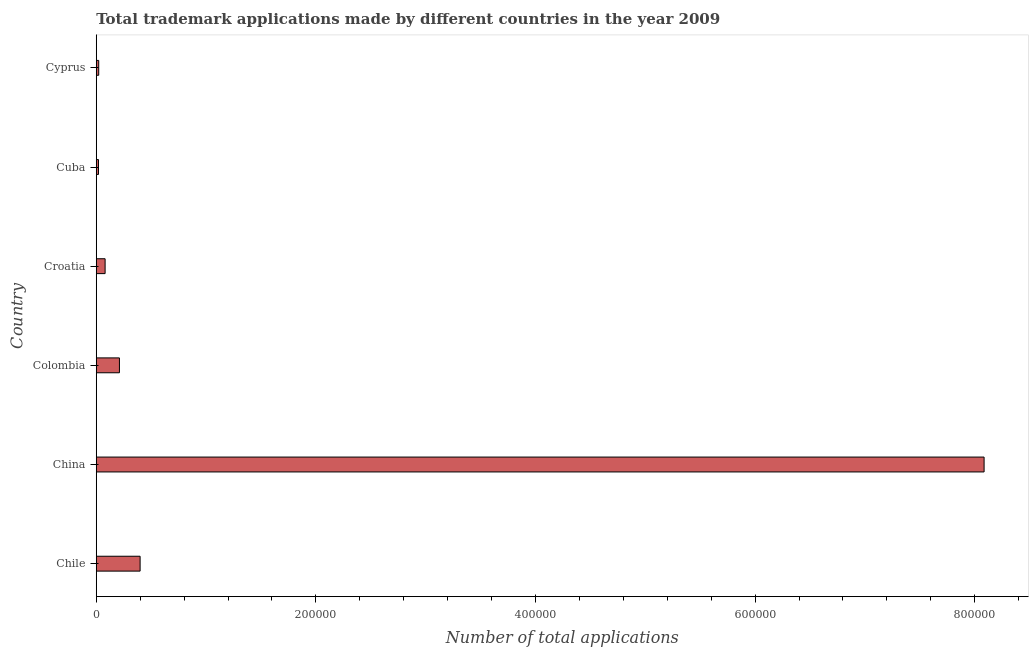Does the graph contain any zero values?
Ensure brevity in your answer.  No. What is the title of the graph?
Your answer should be very brief. Total trademark applications made by different countries in the year 2009. What is the label or title of the X-axis?
Offer a very short reply. Number of total applications. What is the number of trademark applications in Colombia?
Your answer should be very brief. 2.11e+04. Across all countries, what is the maximum number of trademark applications?
Provide a short and direct response. 8.09e+05. Across all countries, what is the minimum number of trademark applications?
Give a very brief answer. 2042. In which country was the number of trademark applications minimum?
Provide a short and direct response. Cuba. What is the sum of the number of trademark applications?
Your answer should be compact. 8.82e+05. What is the difference between the number of trademark applications in Croatia and Cyprus?
Keep it short and to the point. 5811. What is the average number of trademark applications per country?
Keep it short and to the point. 1.47e+05. What is the median number of trademark applications?
Provide a succinct answer. 1.46e+04. What is the ratio of the number of trademark applications in Croatia to that in Cuba?
Your answer should be very brief. 3.94. Is the number of trademark applications in Colombia less than that in Cuba?
Your answer should be compact. No. Is the difference between the number of trademark applications in Chile and China greater than the difference between any two countries?
Your answer should be compact. No. What is the difference between the highest and the second highest number of trademark applications?
Keep it short and to the point. 7.69e+05. What is the difference between the highest and the lowest number of trademark applications?
Offer a terse response. 8.07e+05. In how many countries, is the number of trademark applications greater than the average number of trademark applications taken over all countries?
Provide a short and direct response. 1. How many bars are there?
Provide a succinct answer. 6. How many countries are there in the graph?
Give a very brief answer. 6. What is the difference between two consecutive major ticks on the X-axis?
Make the answer very short. 2.00e+05. Are the values on the major ticks of X-axis written in scientific E-notation?
Your answer should be very brief. No. What is the Number of total applications in Chile?
Your answer should be compact. 3.99e+04. What is the Number of total applications in China?
Offer a very short reply. 8.09e+05. What is the Number of total applications of Colombia?
Offer a very short reply. 2.11e+04. What is the Number of total applications of Croatia?
Provide a succinct answer. 8055. What is the Number of total applications in Cuba?
Give a very brief answer. 2042. What is the Number of total applications of Cyprus?
Make the answer very short. 2244. What is the difference between the Number of total applications in Chile and China?
Ensure brevity in your answer.  -7.69e+05. What is the difference between the Number of total applications in Chile and Colombia?
Provide a short and direct response. 1.88e+04. What is the difference between the Number of total applications in Chile and Croatia?
Your answer should be compact. 3.19e+04. What is the difference between the Number of total applications in Chile and Cuba?
Your answer should be compact. 3.79e+04. What is the difference between the Number of total applications in Chile and Cyprus?
Ensure brevity in your answer.  3.77e+04. What is the difference between the Number of total applications in China and Colombia?
Keep it short and to the point. 7.87e+05. What is the difference between the Number of total applications in China and Croatia?
Your answer should be very brief. 8.00e+05. What is the difference between the Number of total applications in China and Cuba?
Make the answer very short. 8.07e+05. What is the difference between the Number of total applications in China and Cyprus?
Provide a succinct answer. 8.06e+05. What is the difference between the Number of total applications in Colombia and Croatia?
Provide a short and direct response. 1.30e+04. What is the difference between the Number of total applications in Colombia and Cuba?
Offer a very short reply. 1.91e+04. What is the difference between the Number of total applications in Colombia and Cyprus?
Provide a succinct answer. 1.89e+04. What is the difference between the Number of total applications in Croatia and Cuba?
Ensure brevity in your answer.  6013. What is the difference between the Number of total applications in Croatia and Cyprus?
Offer a terse response. 5811. What is the difference between the Number of total applications in Cuba and Cyprus?
Give a very brief answer. -202. What is the ratio of the Number of total applications in Chile to that in China?
Make the answer very short. 0.05. What is the ratio of the Number of total applications in Chile to that in Colombia?
Provide a short and direct response. 1.89. What is the ratio of the Number of total applications in Chile to that in Croatia?
Ensure brevity in your answer.  4.96. What is the ratio of the Number of total applications in Chile to that in Cuba?
Offer a very short reply. 19.56. What is the ratio of the Number of total applications in Chile to that in Cyprus?
Offer a terse response. 17.8. What is the ratio of the Number of total applications in China to that in Colombia?
Your answer should be compact. 38.32. What is the ratio of the Number of total applications in China to that in Croatia?
Make the answer very short. 100.38. What is the ratio of the Number of total applications in China to that in Cuba?
Provide a short and direct response. 395.96. What is the ratio of the Number of total applications in China to that in Cyprus?
Offer a terse response. 360.31. What is the ratio of the Number of total applications in Colombia to that in Croatia?
Your answer should be compact. 2.62. What is the ratio of the Number of total applications in Colombia to that in Cuba?
Keep it short and to the point. 10.33. What is the ratio of the Number of total applications in Colombia to that in Cyprus?
Provide a succinct answer. 9.4. What is the ratio of the Number of total applications in Croatia to that in Cuba?
Your answer should be compact. 3.94. What is the ratio of the Number of total applications in Croatia to that in Cyprus?
Your answer should be very brief. 3.59. What is the ratio of the Number of total applications in Cuba to that in Cyprus?
Provide a succinct answer. 0.91. 